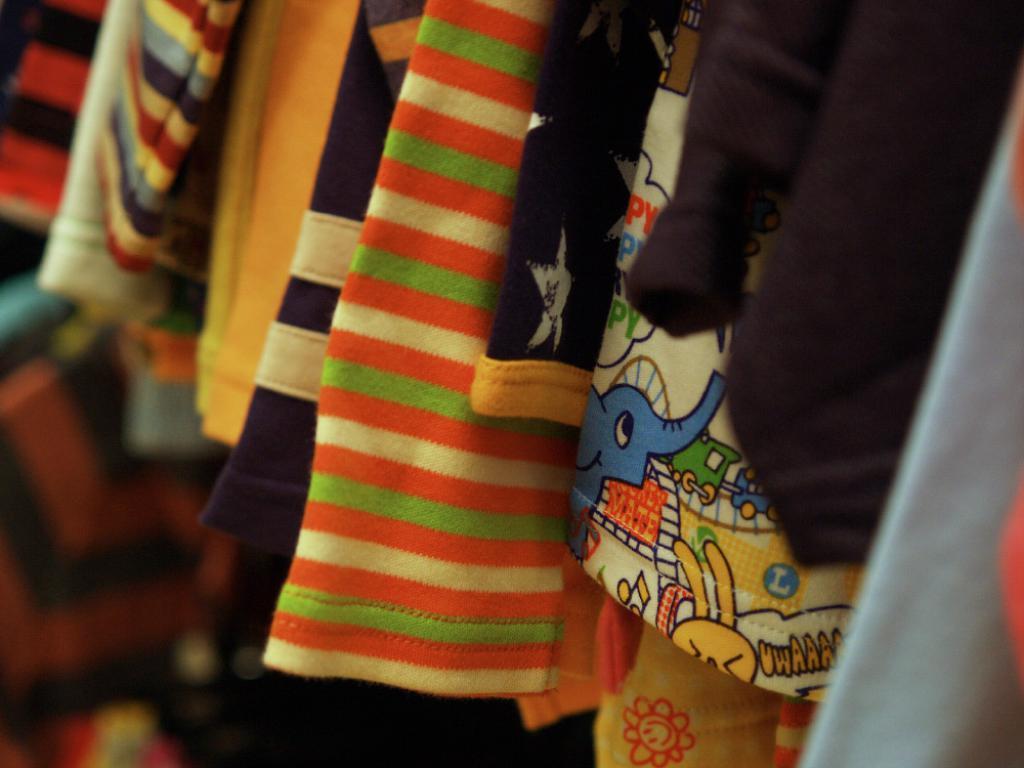Please provide a concise description of this image. There are few clothes which are in different colors. 